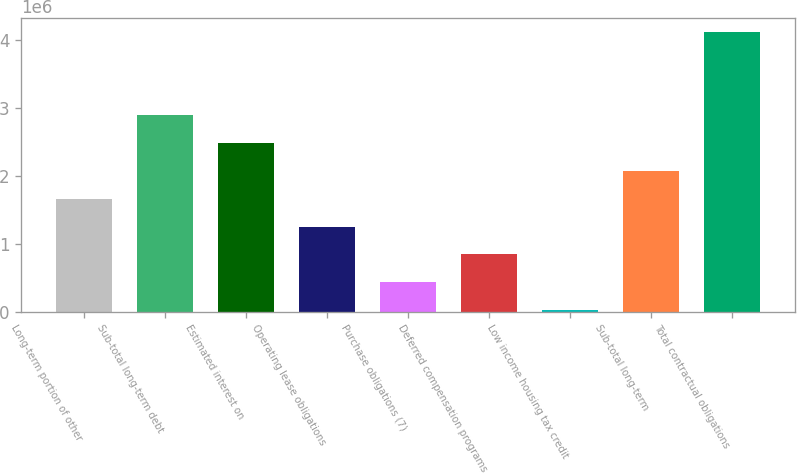Convert chart to OTSL. <chart><loc_0><loc_0><loc_500><loc_500><bar_chart><fcel>Long-term portion of other<fcel>Sub-total long-term debt<fcel>Estimated interest on<fcel>Operating lease obligations<fcel>Purchase obligations (7)<fcel>Deferred compensation programs<fcel>Low income housing tax credit<fcel>Sub-total long-term<fcel>Total contractual obligations<nl><fcel>1.66056e+06<fcel>2.88763e+06<fcel>2.47861e+06<fcel>1.25153e+06<fcel>433478<fcel>842504<fcel>24452<fcel>2.06958e+06<fcel>4.11471e+06<nl></chart> 